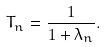Convert formula to latex. <formula><loc_0><loc_0><loc_500><loc_500>T _ { n } = \frac { 1 } { 1 + \lambda _ { n } } .</formula> 